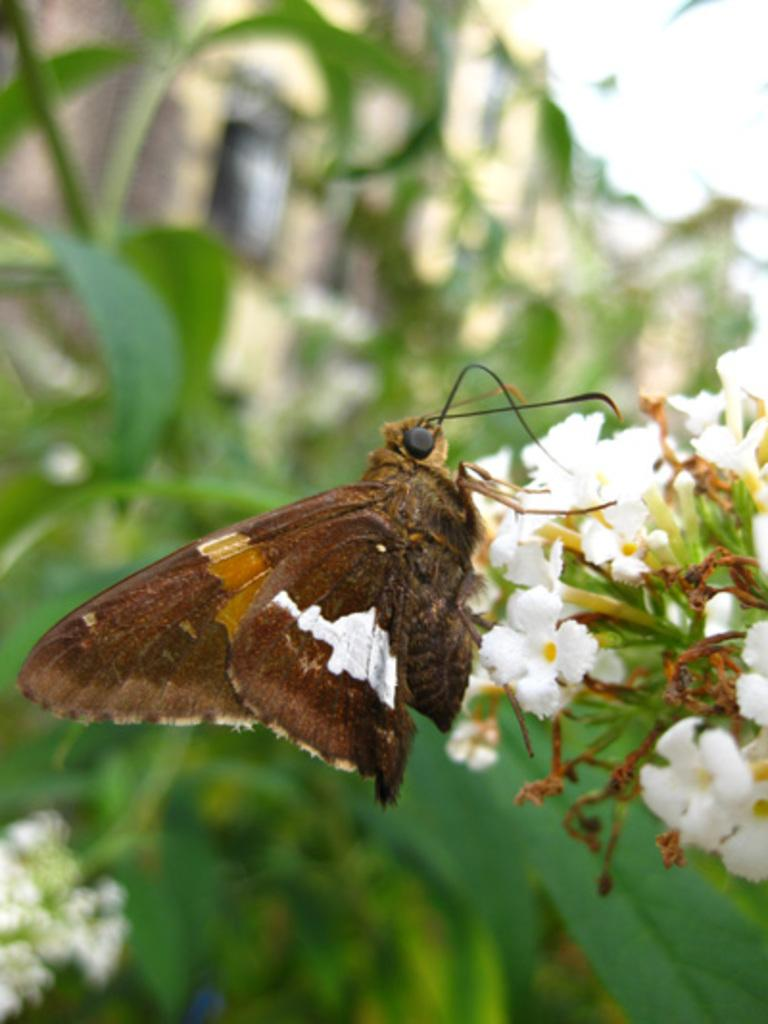What type of flowers are in the image? There are white color flowers in the image. Is there any other living creature present in the image besides the flowers? Yes, there is a butterfly on the flowers. What can be seen in the background of the image? The background is green and blurred. What arithmetic problem is the butterfly solving in the image? There is no arithmetic problem present in the image; it features white flowers and a butterfly. What type of jeans is the butterfly wearing in the image? Butterflies do not wear jeans, as they are insects and do not have the ability to wear clothing. 